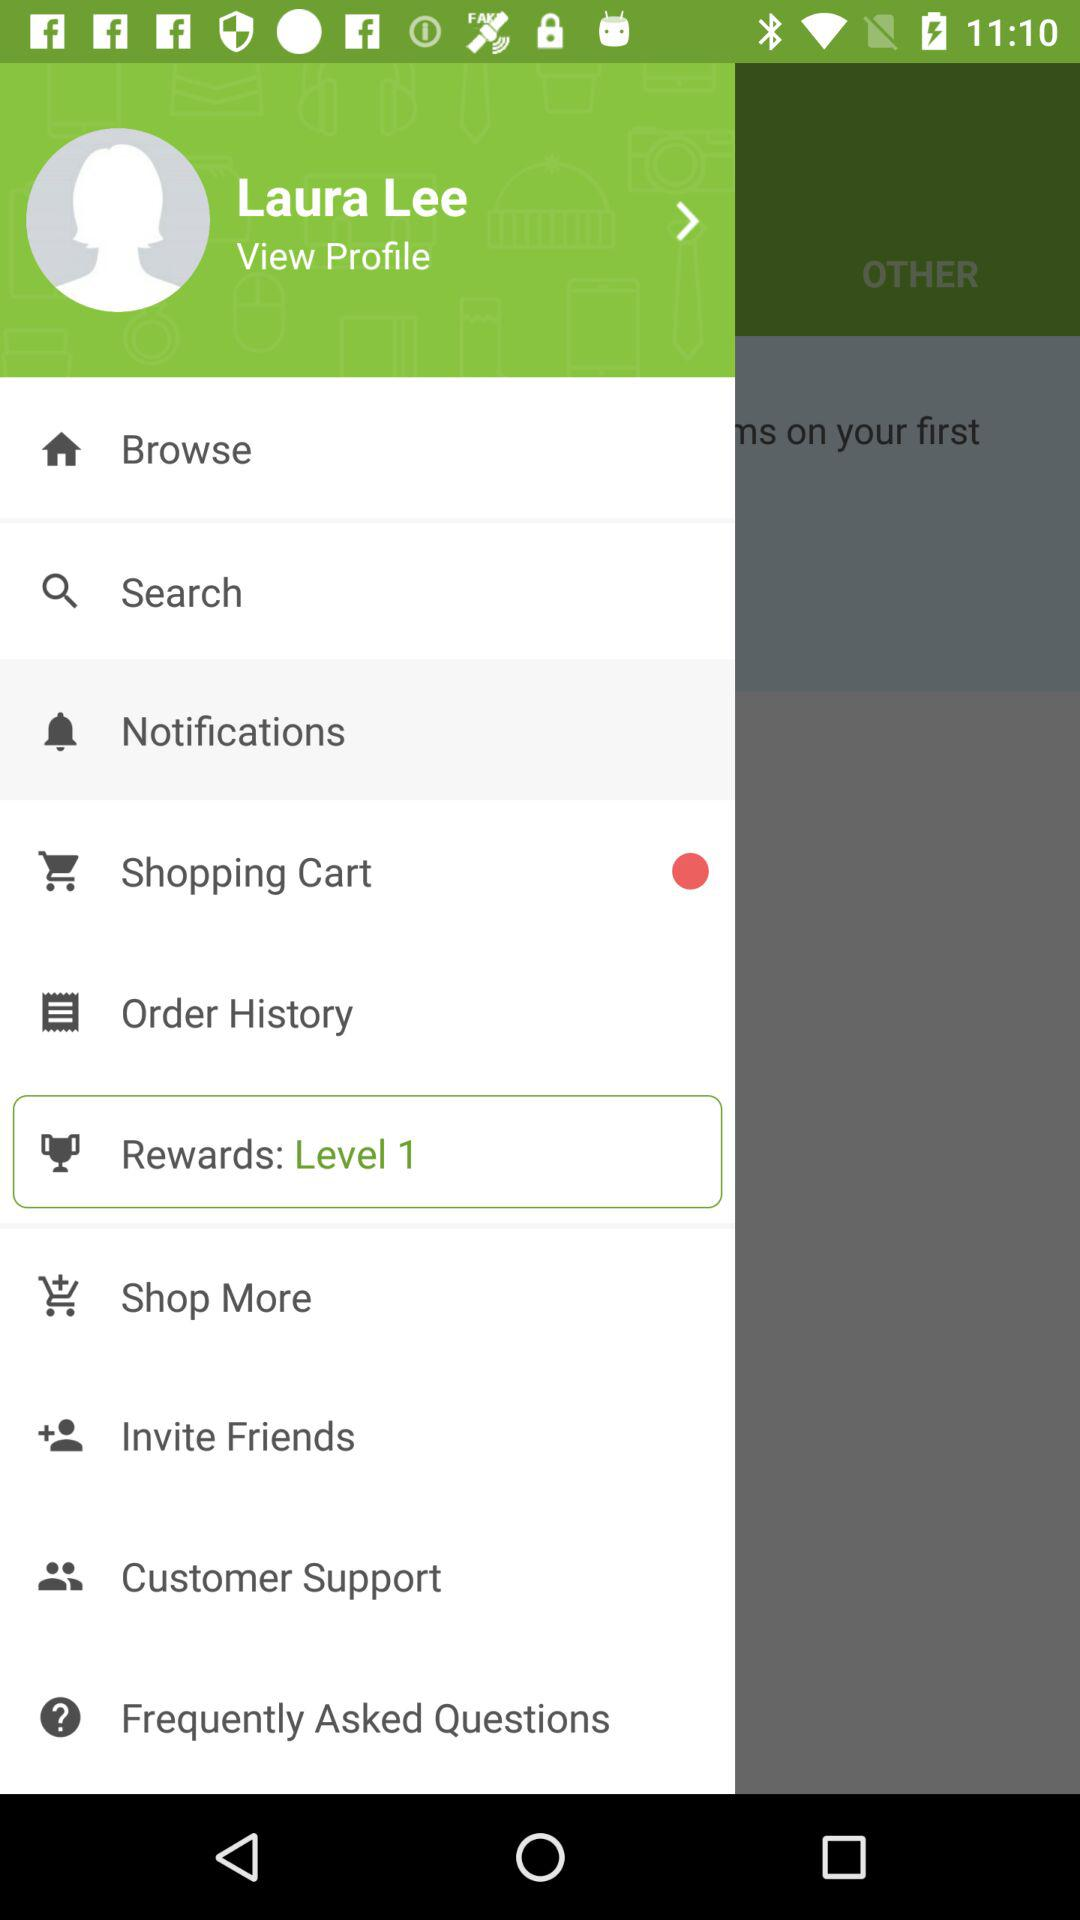How many items have a red circle next to them?
Answer the question using a single word or phrase. 1 